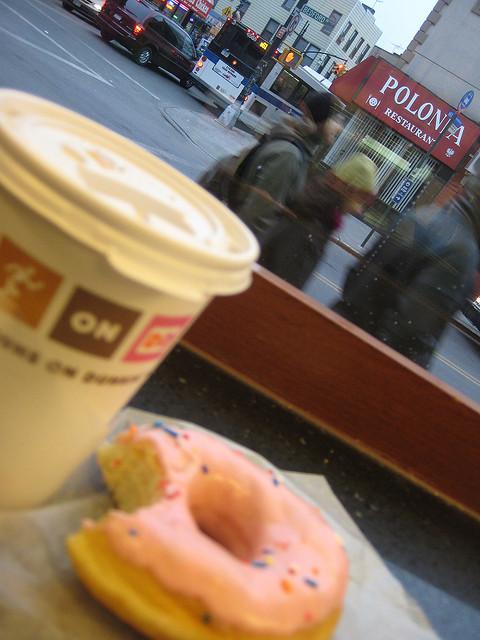How many people are walking by?
Answer briefly. 3. Is this picture taking inside an oven?
Quick response, please. No. What sort of food is this?
Give a very brief answer. Donut. What logo is on the coffee cup?
Quick response, please. Dunkin donuts. What company is on the cup?
Answer briefly. Dunkin donuts. What is this food?
Answer briefly. Donut. Has the doughnut been partially eaten?
Answer briefly. Yes. Is this America?
Write a very short answer. Yes. 